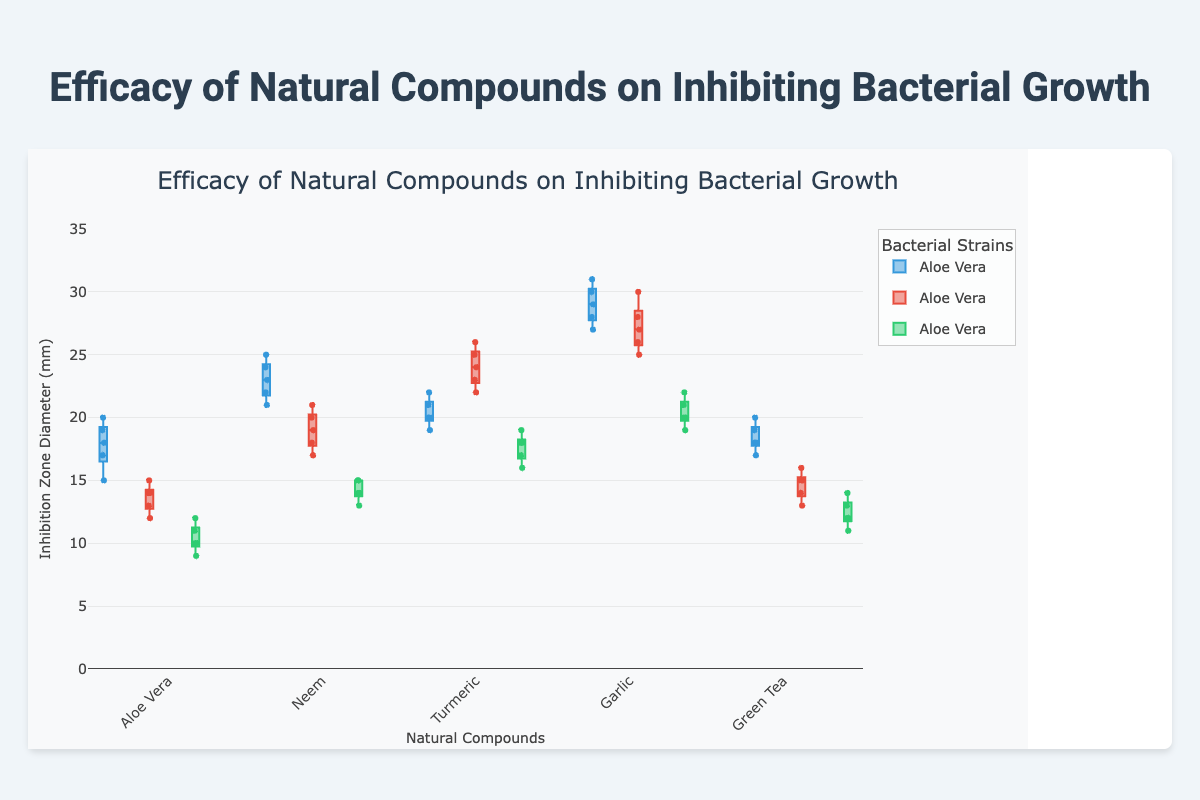Which compound shows the highest median inhibition zone for E. coli? To find the compound with the highest median inhibition zone for E. coli, look at the middle line within the boxes in the E. coli category. Garlic shows the highest median value.
Answer: Garlic How does the range of inhibition zones for S. aureus compare between Neem and Turmeric? The range of the inhibition zones is the difference between the maximum and minimum values observed for each compound. For Neem, the range for S. aureus goes from 17 to 21 (a range of 4). For Turmeric, the range for S. aureus goes from 22 to 26 (a range of 4). Both have the same range.
Answer: Both have the same range Which bacterial strain does Green Tea inhibit the least effectively based on median values? To find the strain that Green Tea inhibits the least, compare the medians of the inhibition zones for E. coli, S. aureus, and P. aeruginosa. P. aeruginosa has the lowest median value.
Answer: P. aeruginosa What is the interquartile range (IQR) for Garlic's inhibition of E. coli? The interquartile range (IQR) is the difference between the third quartile (Q3) and the first quartile (Q1). For Garlic's inhibition of E. coli, Q3 is 30.5 and Q1 is 28.5, so IQR = 30.5 - 28.5.
Answer: 2 Which compound has the most consistent (least variable) inhibition effect on P. aeruginosa? The consistency is indicated by the length of the box which represents the interquartile range (IQR). The shortest box for P. aeruginosa is shown by Neem, indicating the least variability.
Answer: Neem How does the upper whisker of Aloe Vera for E. coli compare to the upper whisker of Garlic for E. coli? The upper whisker extends to the highest data point within 1.5 times the IQR from the third quartile. For Aloe Vera, the upper whisker is at 20, while for Garlic, it is at 31. Garlic's upper whisker is higher.
Answer: Garlic's upper whisker is higher Which bacterial strain has the largest overall range of inhibition zones across all compounds? To determine this, compare the ranges for each strain across all compounds. E. coli has the largest range, from 15 (Aloe Vera) to 31 (Garlic), giving a total range of 16.
Answer: E. coli What is the median inhibition zone for Neem on S. aureus, and how does it compare to that of Turmeric? The median values are represented by the lines within the boxes. For Neem, the median inhibition zone for S. aureus is 19. For Turmeric, it is 24. Turmeric has a higher median value.
Answer: Turmeric has a higher median value 